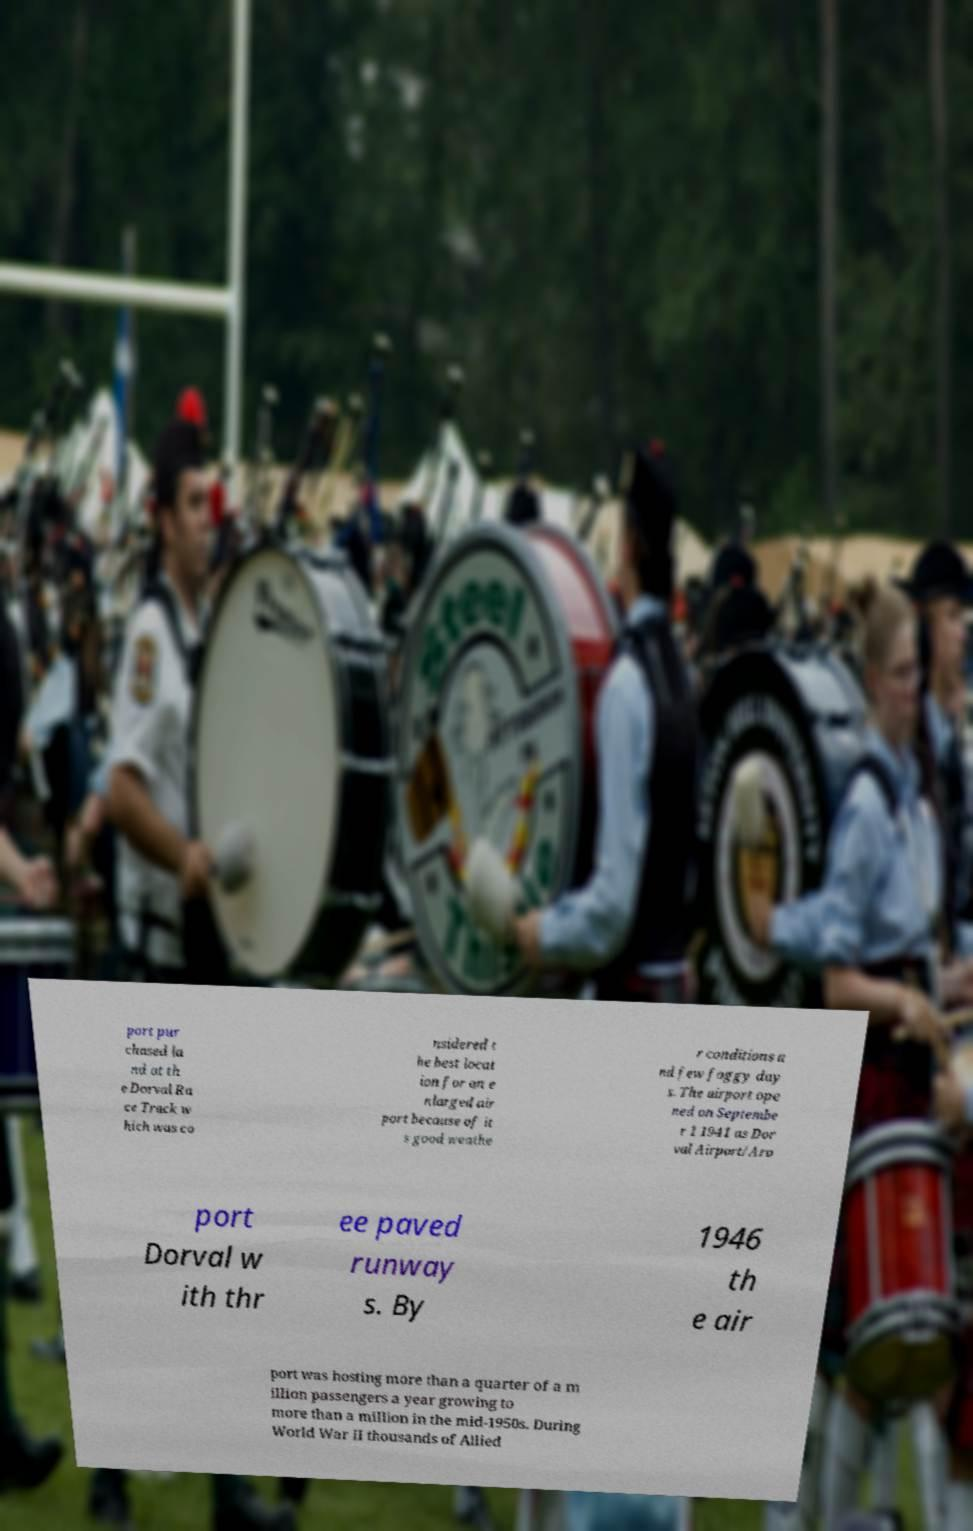I need the written content from this picture converted into text. Can you do that? port pur chased la nd at th e Dorval Ra ce Track w hich was co nsidered t he best locat ion for an e nlarged air port because of it s good weathe r conditions a nd few foggy day s. The airport ope ned on Septembe r 1 1941 as Dor val Airport/Aro port Dorval w ith thr ee paved runway s. By 1946 th e air port was hosting more than a quarter of a m illion passengers a year growing to more than a million in the mid-1950s. During World War II thousands of Allied 